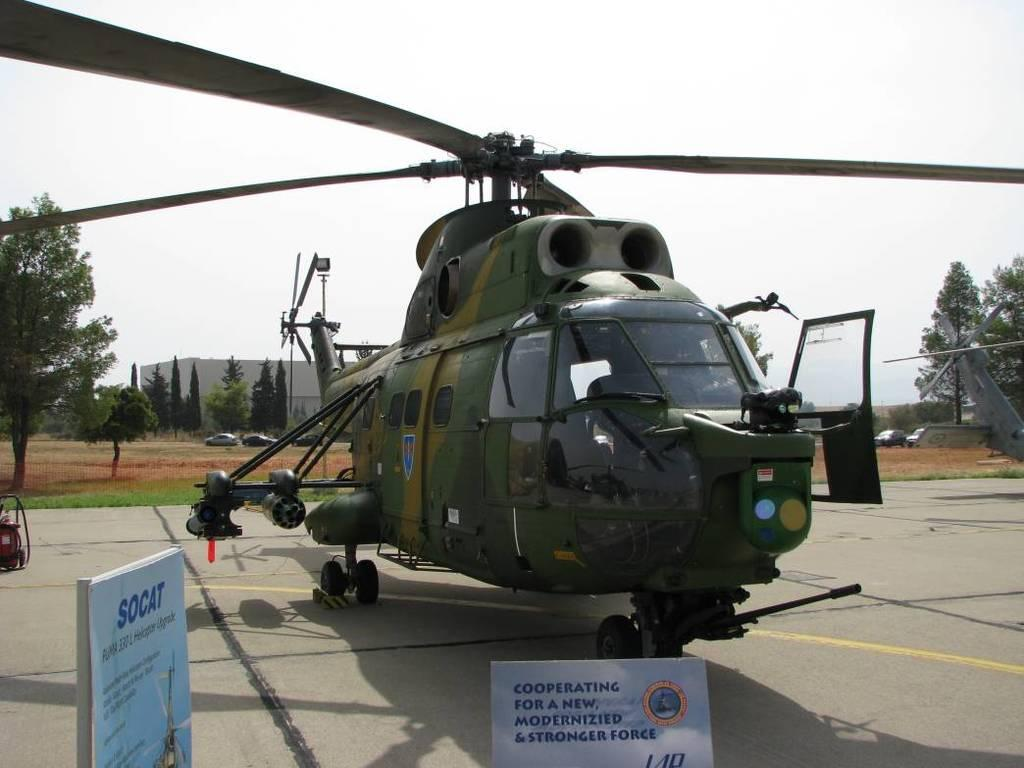<image>
Relay a brief, clear account of the picture shown. A SOCAT helicopter is displayed behind a sign that says Cooperating for a new modernizied & stronger force. 